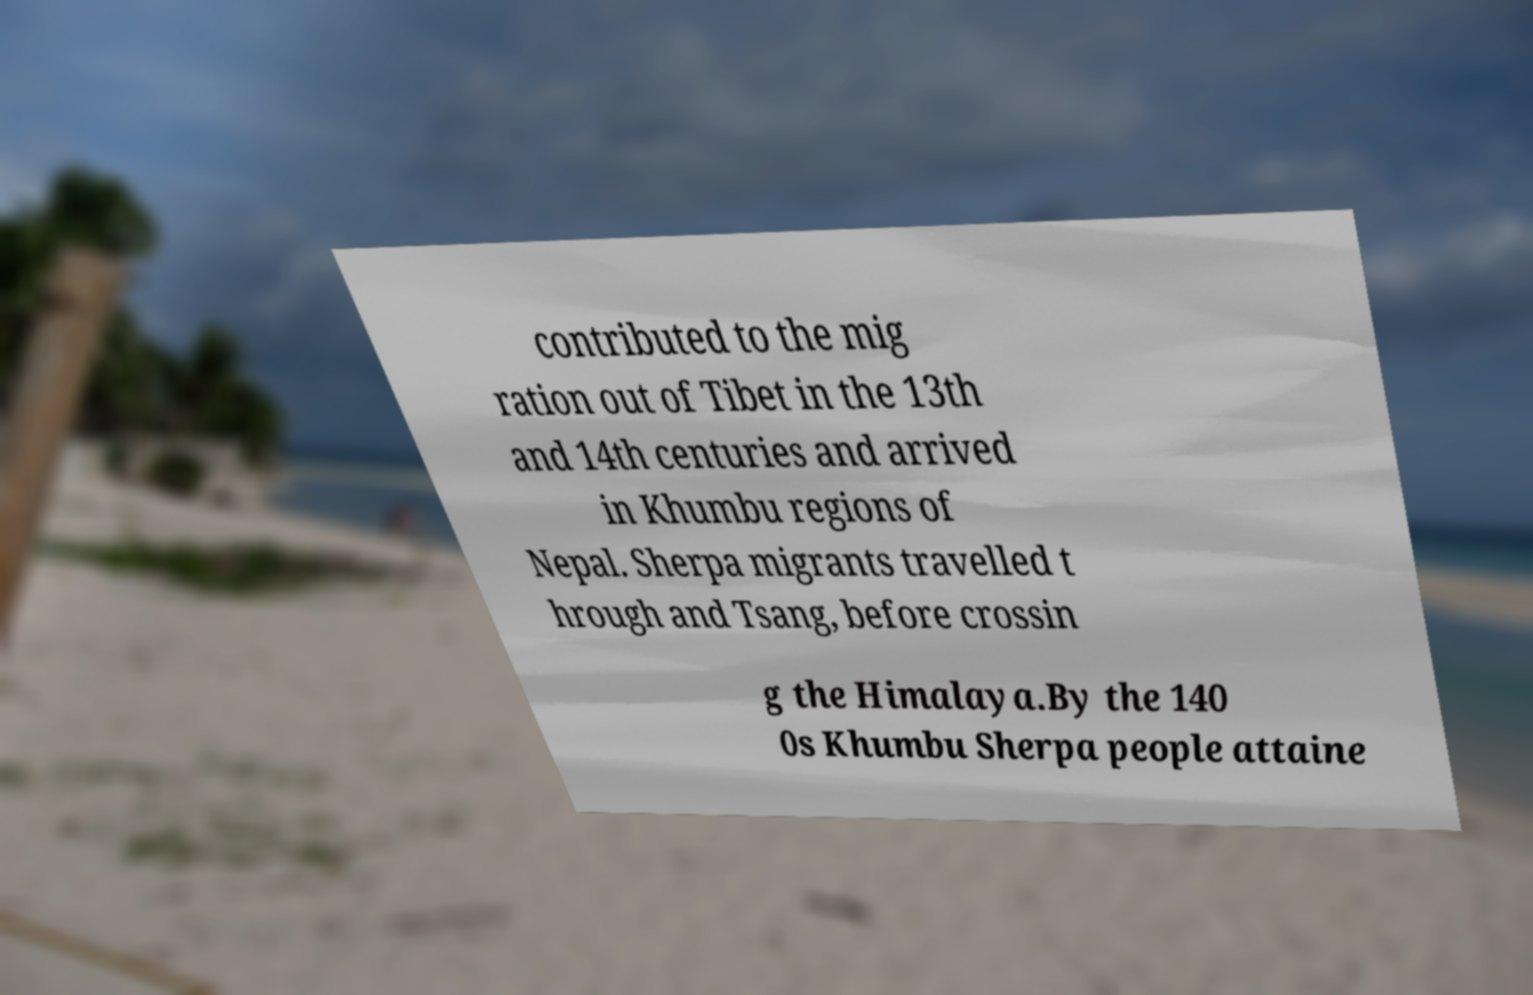Can you accurately transcribe the text from the provided image for me? contributed to the mig ration out of Tibet in the 13th and 14th centuries and arrived in Khumbu regions of Nepal. Sherpa migrants travelled t hrough and Tsang, before crossin g the Himalaya.By the 140 0s Khumbu Sherpa people attaine 